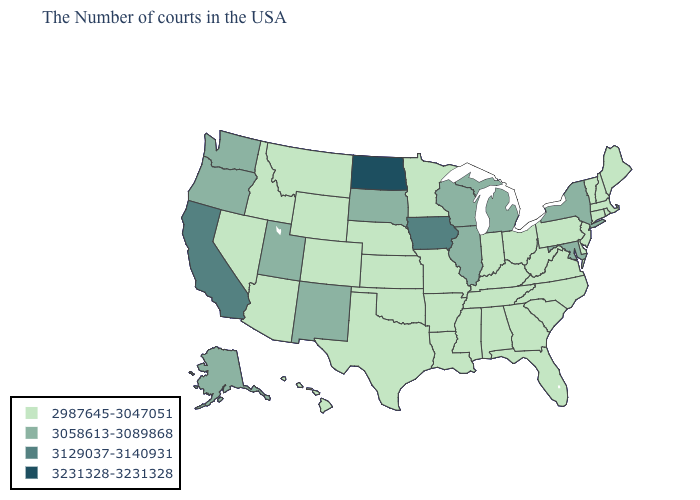What is the value of Washington?
Answer briefly. 3058613-3089868. Does North Carolina have a lower value than Colorado?
Give a very brief answer. No. Does the first symbol in the legend represent the smallest category?
Be succinct. Yes. Name the states that have a value in the range 2987645-3047051?
Give a very brief answer. Maine, Massachusetts, Rhode Island, New Hampshire, Vermont, Connecticut, New Jersey, Delaware, Pennsylvania, Virginia, North Carolina, South Carolina, West Virginia, Ohio, Florida, Georgia, Kentucky, Indiana, Alabama, Tennessee, Mississippi, Louisiana, Missouri, Arkansas, Minnesota, Kansas, Nebraska, Oklahoma, Texas, Wyoming, Colorado, Montana, Arizona, Idaho, Nevada, Hawaii. Does South Dakota have the same value as Maryland?
Be succinct. Yes. Name the states that have a value in the range 2987645-3047051?
Keep it brief. Maine, Massachusetts, Rhode Island, New Hampshire, Vermont, Connecticut, New Jersey, Delaware, Pennsylvania, Virginia, North Carolina, South Carolina, West Virginia, Ohio, Florida, Georgia, Kentucky, Indiana, Alabama, Tennessee, Mississippi, Louisiana, Missouri, Arkansas, Minnesota, Kansas, Nebraska, Oklahoma, Texas, Wyoming, Colorado, Montana, Arizona, Idaho, Nevada, Hawaii. What is the value of Florida?
Be succinct. 2987645-3047051. What is the value of California?
Write a very short answer. 3129037-3140931. Name the states that have a value in the range 2987645-3047051?
Concise answer only. Maine, Massachusetts, Rhode Island, New Hampshire, Vermont, Connecticut, New Jersey, Delaware, Pennsylvania, Virginia, North Carolina, South Carolina, West Virginia, Ohio, Florida, Georgia, Kentucky, Indiana, Alabama, Tennessee, Mississippi, Louisiana, Missouri, Arkansas, Minnesota, Kansas, Nebraska, Oklahoma, Texas, Wyoming, Colorado, Montana, Arizona, Idaho, Nevada, Hawaii. Does Georgia have a lower value than Delaware?
Keep it brief. No. What is the highest value in the West ?
Quick response, please. 3129037-3140931. Name the states that have a value in the range 3058613-3089868?
Quick response, please. New York, Maryland, Michigan, Wisconsin, Illinois, South Dakota, New Mexico, Utah, Washington, Oregon, Alaska. What is the highest value in the South ?
Write a very short answer. 3058613-3089868. What is the value of Maryland?
Short answer required. 3058613-3089868. How many symbols are there in the legend?
Write a very short answer. 4. 